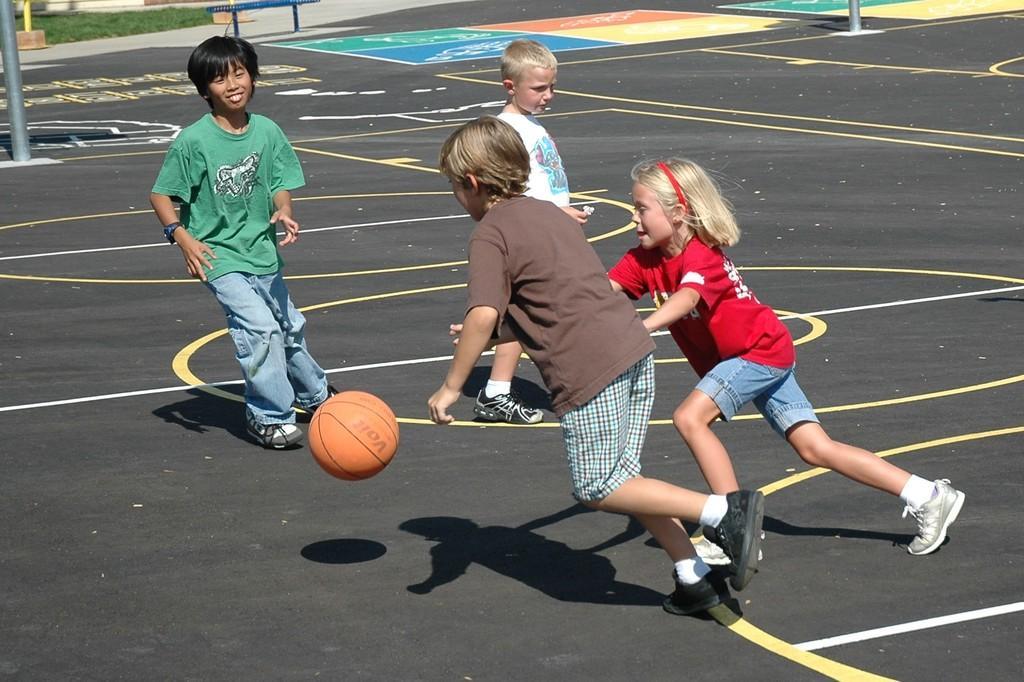Could you give a brief overview of what you see in this image? In this image we can see few children playing basketball. We can see a basketball court in the image. There are few poles in the image. There is a bench at the top of the image. 